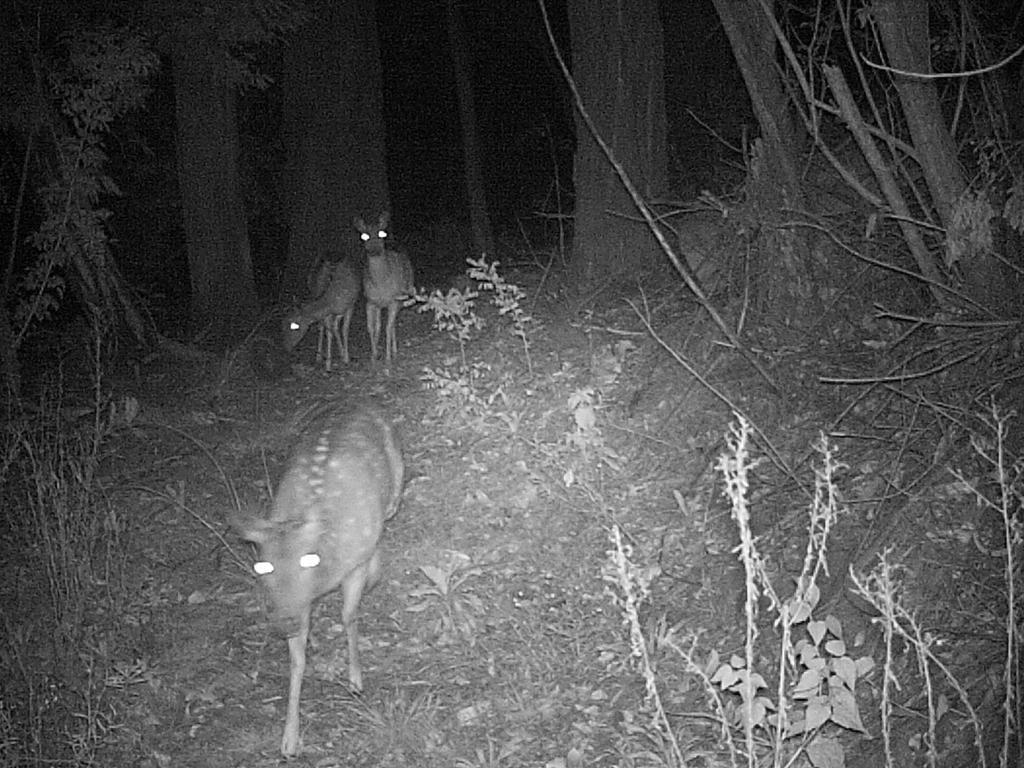Describe this image in one or two sentences. In this picture we can see three animals, plants on the ground, trees and in the background it is dark. 